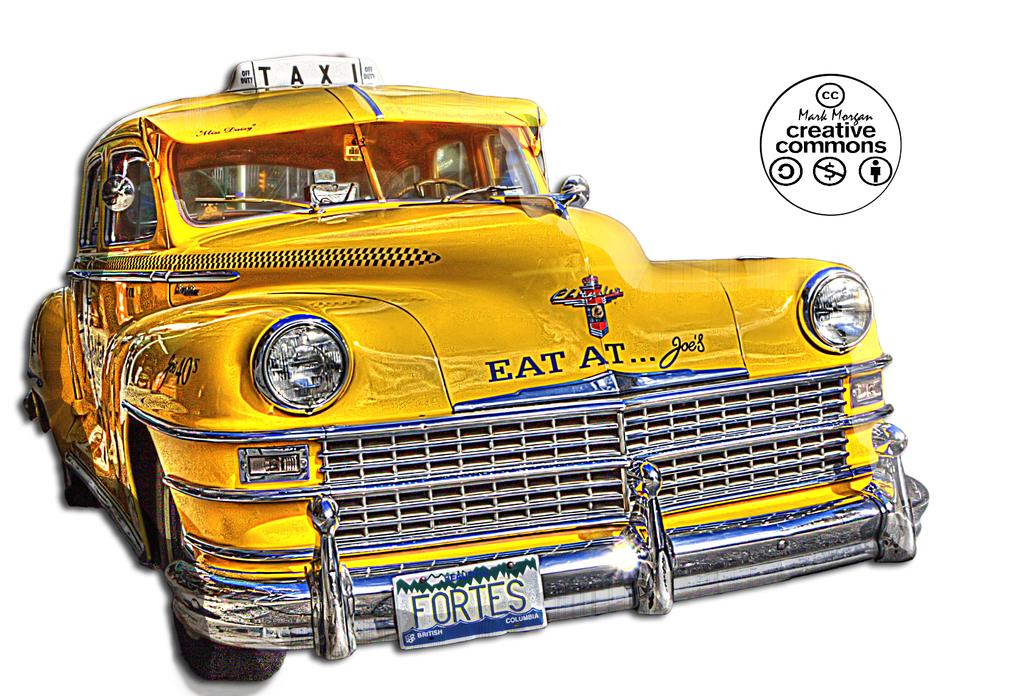<image>
Summarize the visual content of the image. Yellow taxi with the words "Eat at" in the front. 